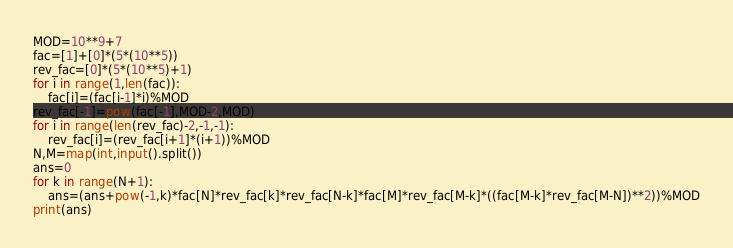Convert code to text. <code><loc_0><loc_0><loc_500><loc_500><_Python_>MOD=10**9+7
fac=[1]+[0]*(5*(10**5))
rev_fac=[0]*(5*(10**5)+1)
for i in range(1,len(fac)):
    fac[i]=(fac[i-1]*i)%MOD
rev_fac[-1]=pow(fac[-1],MOD-2,MOD)
for i in range(len(rev_fac)-2,-1,-1):
    rev_fac[i]=(rev_fac[i+1]*(i+1))%MOD
N,M=map(int,input().split())
ans=0
for k in range(N+1):
    ans=(ans+pow(-1,k)*fac[N]*rev_fac[k]*rev_fac[N-k]*fac[M]*rev_fac[M-k]*((fac[M-k]*rev_fac[M-N])**2))%MOD
print(ans)</code> 